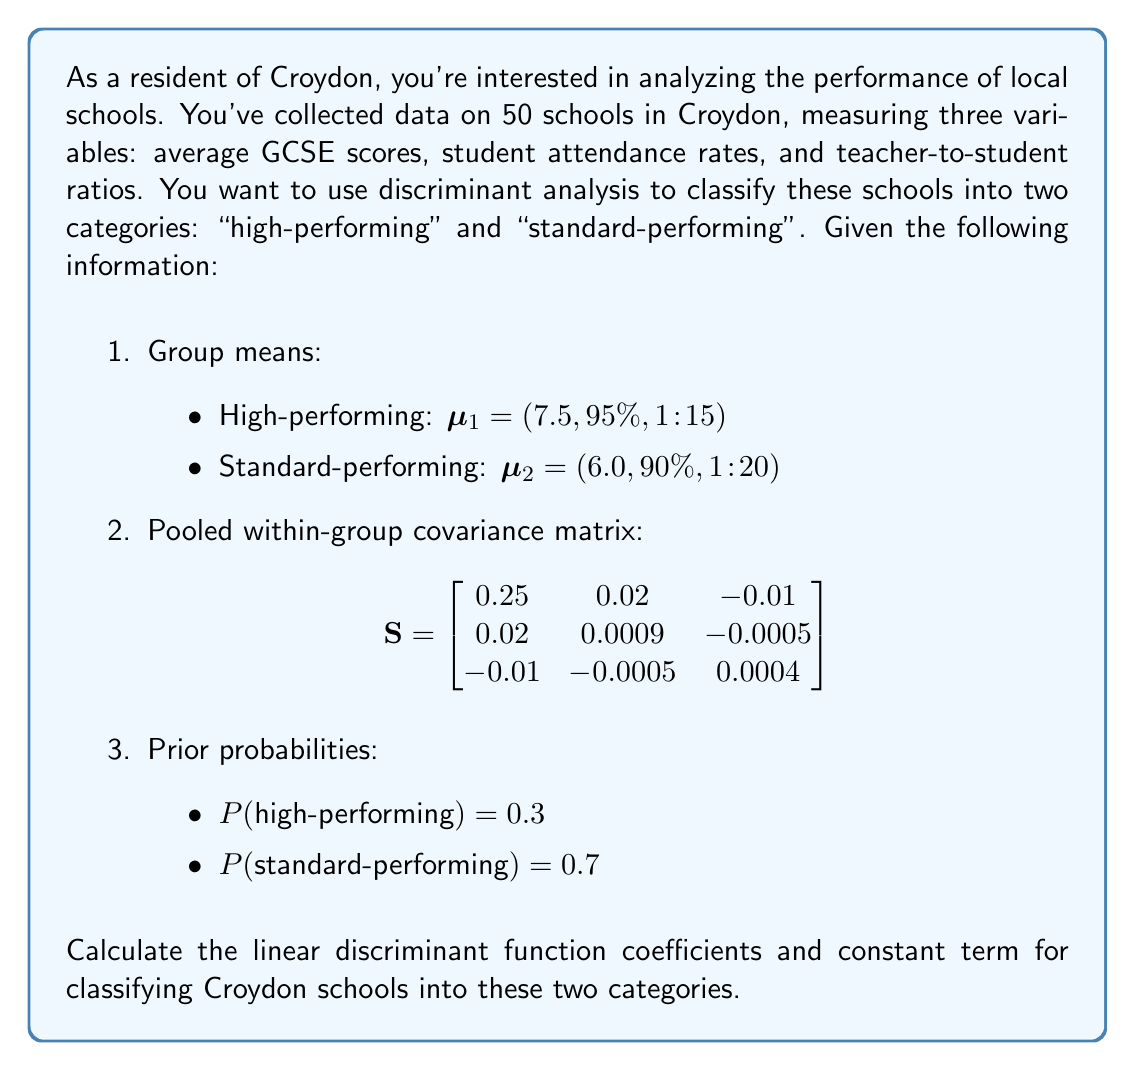Teach me how to tackle this problem. To solve this problem, we'll use Fisher's linear discriminant analysis. The steps are as follows:

1. Calculate the difference between group means:
   $\Delta\mu = \mu_1 - \mu_2 = (1.5, 5\%, -5)$

2. Calculate the linear discriminant function coefficients:
   $a = S^{-1}\Delta\mu$

   First, we need to find the inverse of S:
   $$S^{-1} = \begin{bmatrix}
   4.1667 & -83.3333 & 83.3333 \\
   -83.3333 & 2777.7778 & -1388.8889 \\
   83.3333 & -1388.8889 & 5555.5556
   \end{bmatrix}$$

   Now, we can calculate $a$:
   $$a = S^{-1}\Delta\mu = \begin{bmatrix}
   4.1667 & -83.3333 & 83.3333 \\
   -83.3333 & 2777.7778 & -1388.8889 \\
   83.3333 & -1388.8889 & 5555.5556
   \end{bmatrix} \begin{bmatrix}
   1.5 \\
   0.05 \\
   -0.05
   \end{bmatrix}$$

   $$a = \begin{bmatrix}
   6.25 \\
   138.89 \\
   -277.78
   \end{bmatrix}$$

3. Calculate the constant term:
   $c = -\frac{1}{2}a^T(\mu_1 + \mu_2) + \ln\frac{P(\text{high-performing})}{P(\text{standard-performing})}$

   $c = -\frac{1}{2}(6.25 \cdot 13.5 + 138.89 \cdot 1.85 + (-277.78) \cdot (-0.0375)) + \ln\frac{0.3}{0.7}$

   $c = -\frac{1}{2}(84.375 + 257.1465 + 10.41675) + (-0.8472)$

   $c = -175.97 - 0.8472 = -176.8172$

The linear discriminant function is:
$f(x) = 6.25x_1 + 138.89x_2 - 277.78x_3 - 176.8172$

Where:
$x_1$ is the average GCSE score
$x_2$ is the student attendance rate (as a decimal)
$x_3$ is the teacher-to-student ratio (as a decimal)

To classify a school, calculate $f(x)$ for its metrics. If $f(x) > 0$, classify as high-performing; if $f(x) < 0$, classify as standard-performing.
Answer: Linear discriminant function coefficients:
$a_1 = 6.25$
$a_2 = 138.89$
$a_3 = -277.78$

Constant term:
$c = -176.8172$ 